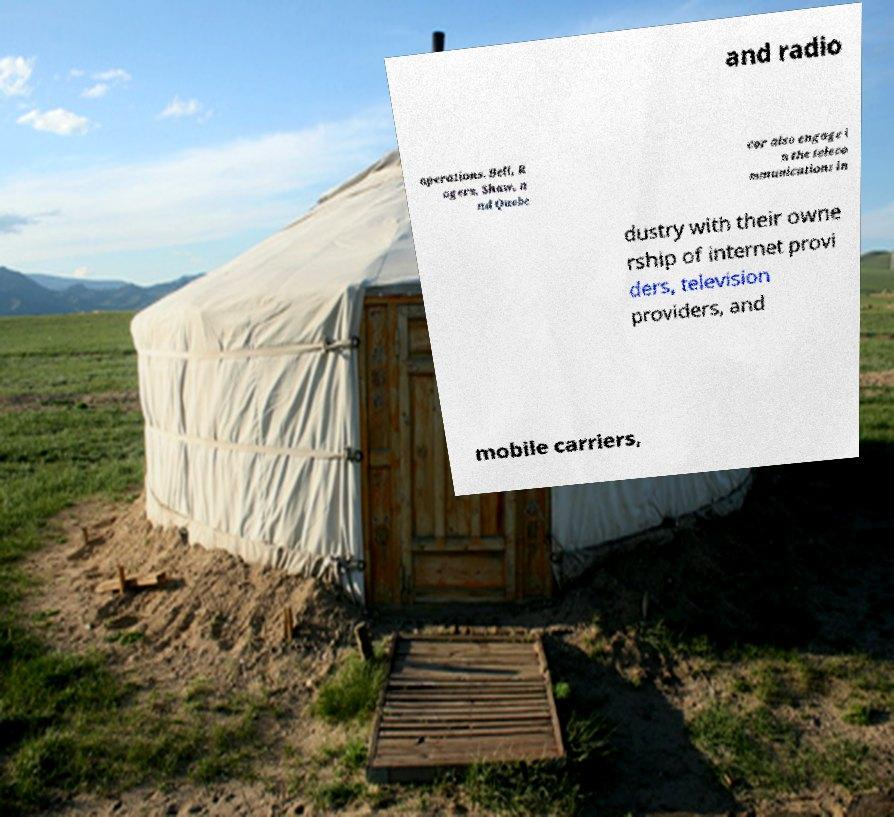Please identify and transcribe the text found in this image. and radio operations. Bell, R ogers, Shaw, a nd Quebe cor also engage i n the teleco mmunications in dustry with their owne rship of internet provi ders, television providers, and mobile carriers, 